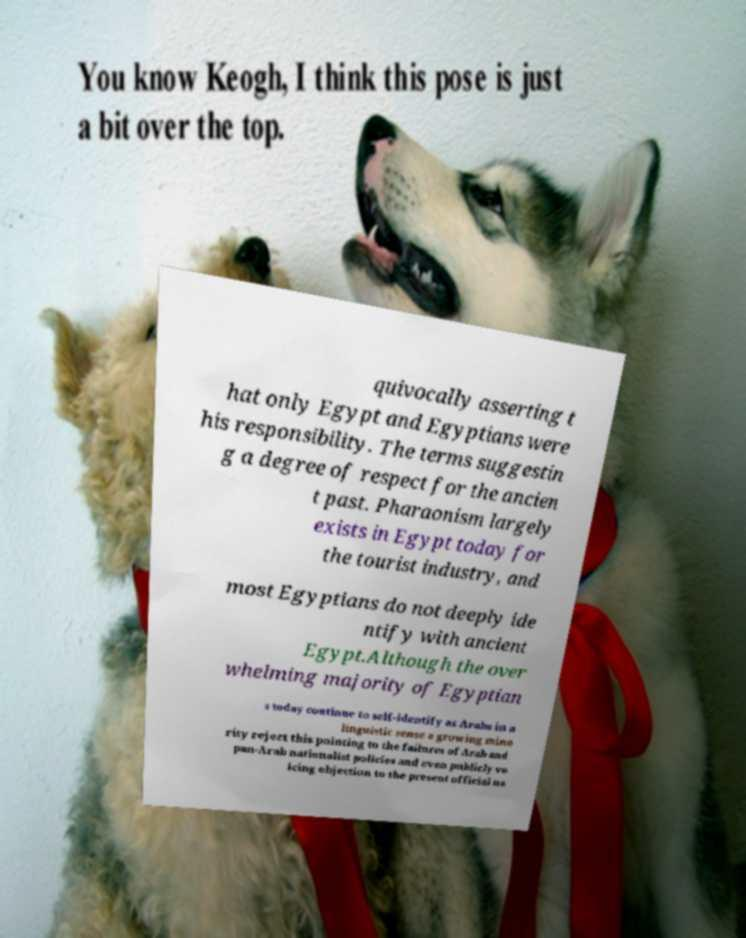Could you assist in decoding the text presented in this image and type it out clearly? quivocally asserting t hat only Egypt and Egyptians were his responsibility. The terms suggestin g a degree of respect for the ancien t past. Pharaonism largely exists in Egypt today for the tourist industry, and most Egyptians do not deeply ide ntify with ancient Egypt.Although the over whelming majority of Egyptian s today continue to self-identify as Arabs in a linguistic sense a growing mino rity reject this pointing to the failures of Arab and pan-Arab nationalist policies and even publicly vo icing objection to the present official na 